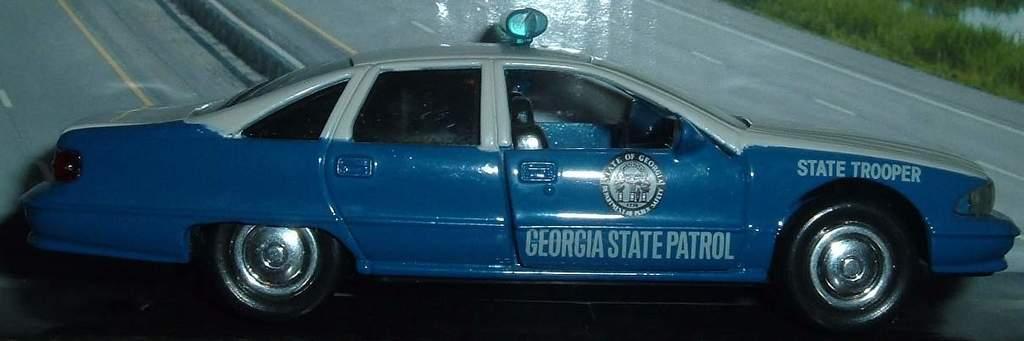How would you summarize this image in a sentence or two? In this image, we can see a car on the black surface. Background we can see road and grass. 